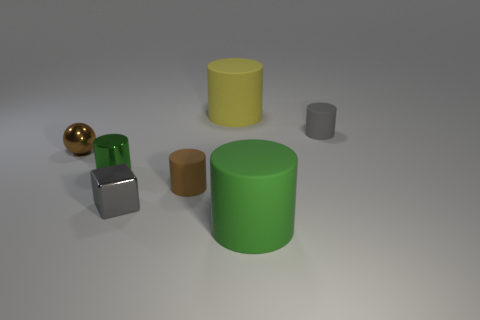Subtract 1 cylinders. How many cylinders are left? 4 Subtract all gray cylinders. How many cylinders are left? 4 Subtract all green shiny cylinders. How many cylinders are left? 4 Subtract all blue cylinders. Subtract all yellow balls. How many cylinders are left? 5 Add 3 blocks. How many objects exist? 10 Subtract all cubes. How many objects are left? 6 Subtract 1 gray blocks. How many objects are left? 6 Subtract all small cyan cylinders. Subtract all small brown matte things. How many objects are left? 6 Add 6 spheres. How many spheres are left? 7 Add 1 large cyan rubber things. How many large cyan rubber things exist? 1 